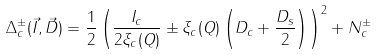Convert formula to latex. <formula><loc_0><loc_0><loc_500><loc_500>\Delta _ { c } ^ { \pm } ( \vec { I } , \vec { D } ) = \frac { 1 } { 2 } \left ( \frac { I _ { c } } { 2 \xi _ { c } ( Q ) } \pm \xi _ { c } ( Q ) \left ( D _ { c } + \frac { D _ { s } } { 2 } \right ) \right ) ^ { 2 } + N _ { c } ^ { \pm }</formula> 